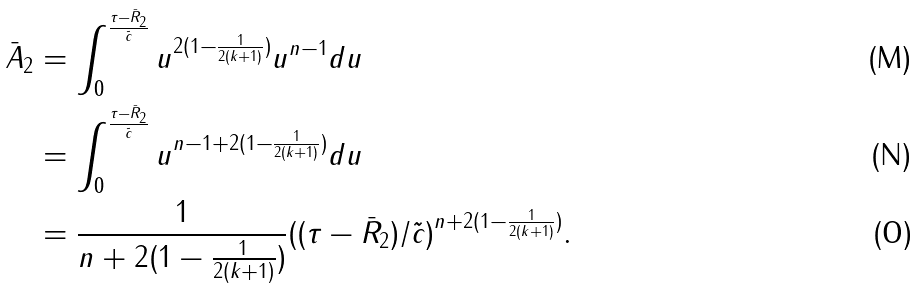<formula> <loc_0><loc_0><loc_500><loc_500>\bar { A } _ { 2 } & = \int _ { 0 } ^ { \frac { \tau - \bar { R } _ { 2 } } { \tilde { c } } } u ^ { 2 ( 1 - \frac { 1 } { 2 ( k + 1 ) } ) } u ^ { n - 1 } d u \\ & = \int _ { 0 } ^ { \frac { \tau - \bar { R } _ { 2 } } { \tilde { c } } } u ^ { n - 1 + 2 ( 1 - \frac { 1 } { 2 ( k + 1 ) } ) } d u \\ & = \frac { 1 } { n + 2 ( 1 - \frac { 1 } { 2 ( k + 1 ) } ) } ( ( \tau - \bar { R } _ { 2 } ) / \tilde { c } ) ^ { n + 2 ( 1 - \frac { 1 } { 2 ( k + 1 ) } ) } .</formula> 